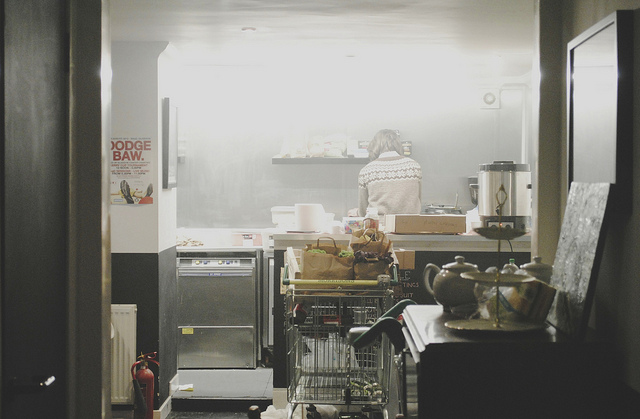Identify the text displayed in this image. ODGE BAW. 